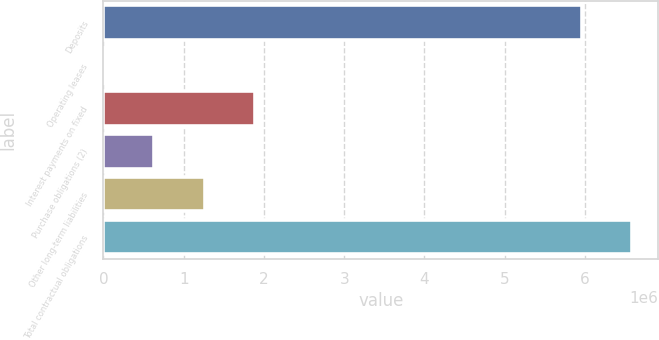Convert chart to OTSL. <chart><loc_0><loc_0><loc_500><loc_500><bar_chart><fcel>Deposits<fcel>Operating leases<fcel>Interest payments on fixed<fcel>Purchase obligations (2)<fcel>Other long-term liabilities<fcel>Total contractual obligations<nl><fcel>5.9582e+06<fcel>9167<fcel>1.88933e+06<fcel>635889<fcel>1.26261e+06<fcel>6.58492e+06<nl></chart> 